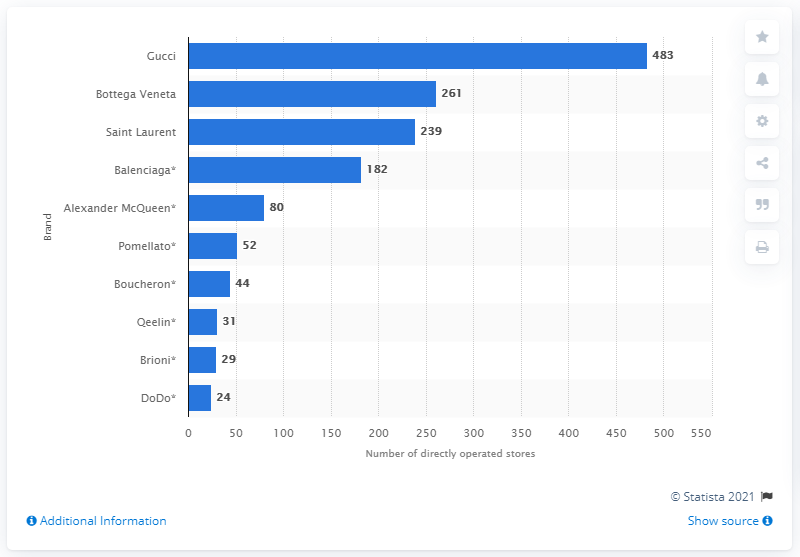Highlight a few significant elements in this photo. In 2020, Kering owned and operated a total of 483 Gucci stores worldwide. 